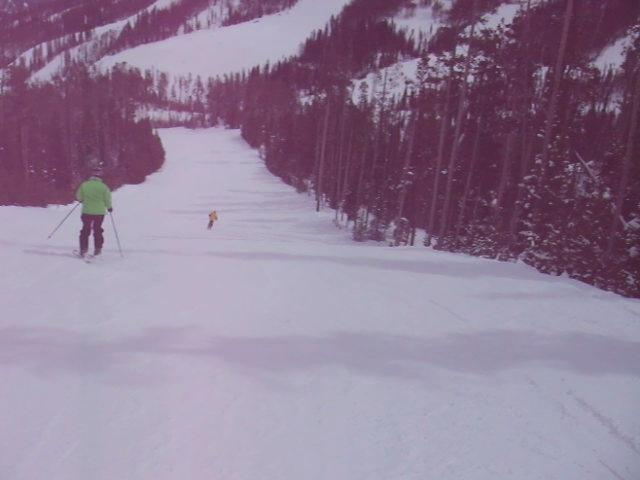What sport would this be if gates were added?

Choices:
A) slalom
B) ski jump
C) moguls
D) downhill moguls 